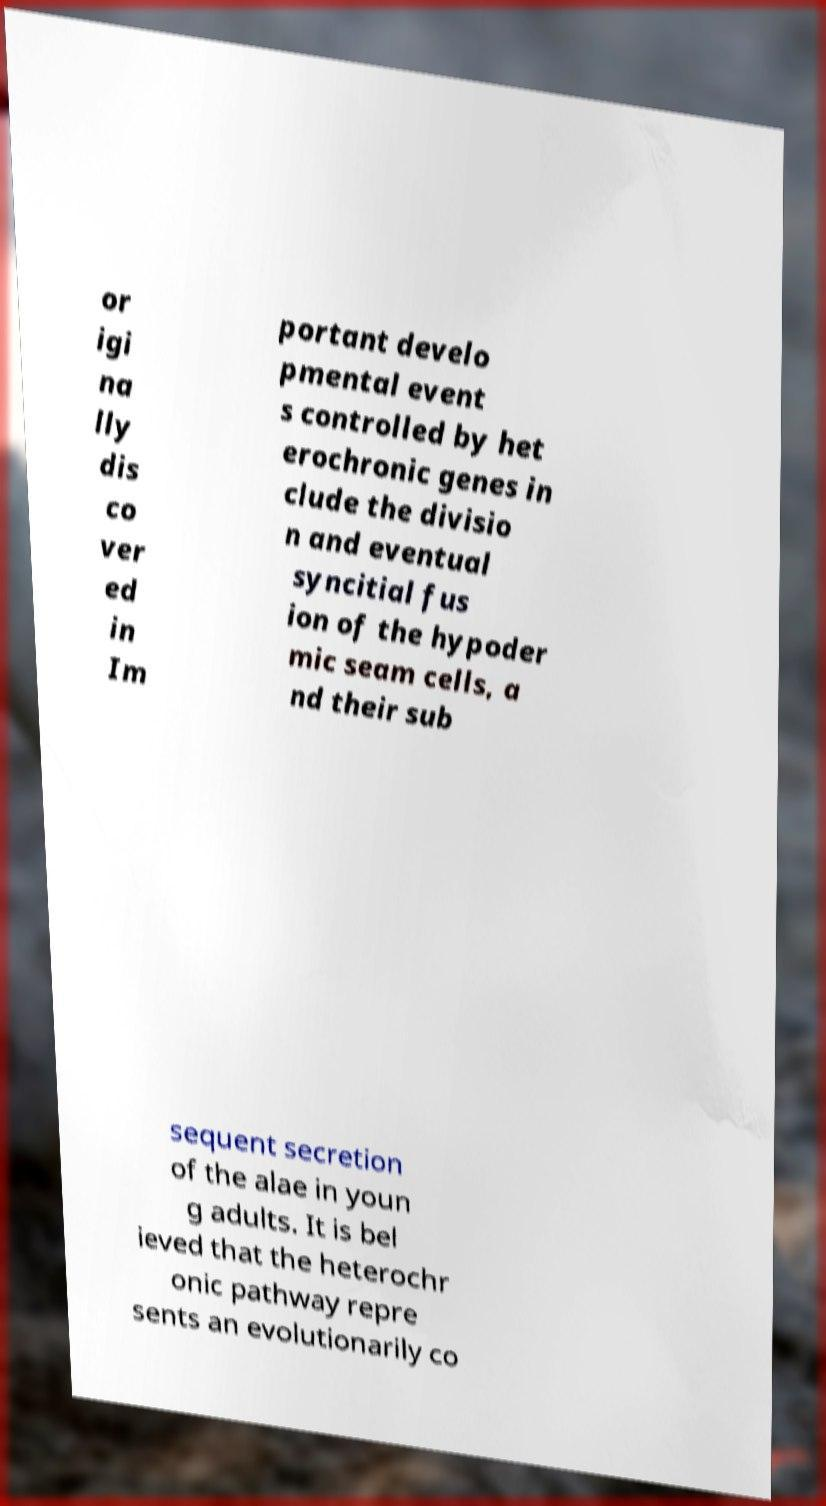There's text embedded in this image that I need extracted. Can you transcribe it verbatim? or igi na lly dis co ver ed in Im portant develo pmental event s controlled by het erochronic genes in clude the divisio n and eventual syncitial fus ion of the hypoder mic seam cells, a nd their sub sequent secretion of the alae in youn g adults. It is bel ieved that the heterochr onic pathway repre sents an evolutionarily co 